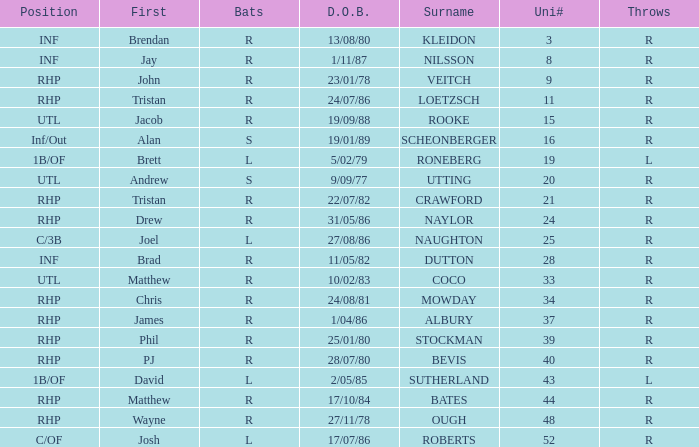Which Position has a Surname of naylor? RHP. 